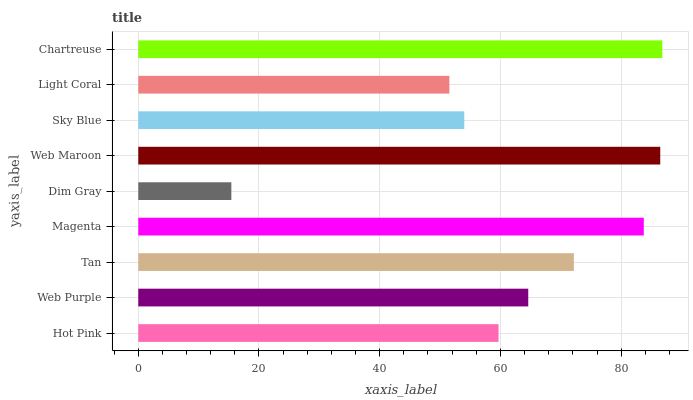Is Dim Gray the minimum?
Answer yes or no. Yes. Is Chartreuse the maximum?
Answer yes or no. Yes. Is Web Purple the minimum?
Answer yes or no. No. Is Web Purple the maximum?
Answer yes or no. No. Is Web Purple greater than Hot Pink?
Answer yes or no. Yes. Is Hot Pink less than Web Purple?
Answer yes or no. Yes. Is Hot Pink greater than Web Purple?
Answer yes or no. No. Is Web Purple less than Hot Pink?
Answer yes or no. No. Is Web Purple the high median?
Answer yes or no. Yes. Is Web Purple the low median?
Answer yes or no. Yes. Is Tan the high median?
Answer yes or no. No. Is Magenta the low median?
Answer yes or no. No. 